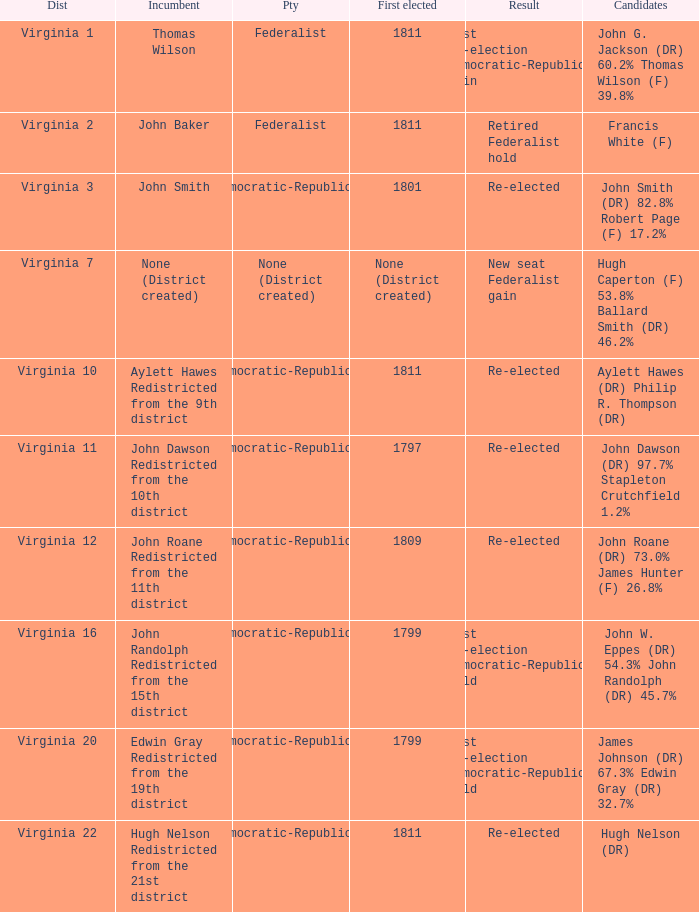Name the party for virginia 12 Democratic-Republican. 